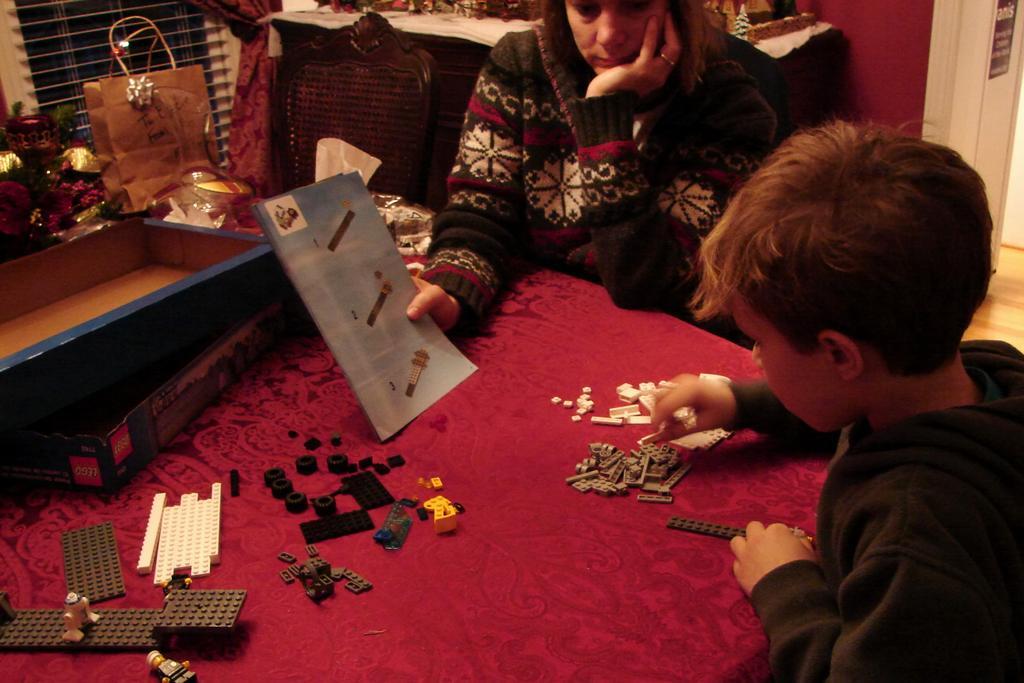Please provide a concise description of this image. There is a room. The people are sitting in a chair. He is playing with Legos. She is holding a paper. There is a table. There is a legos on a table. We can see in the background there is a chair,window and bag. 